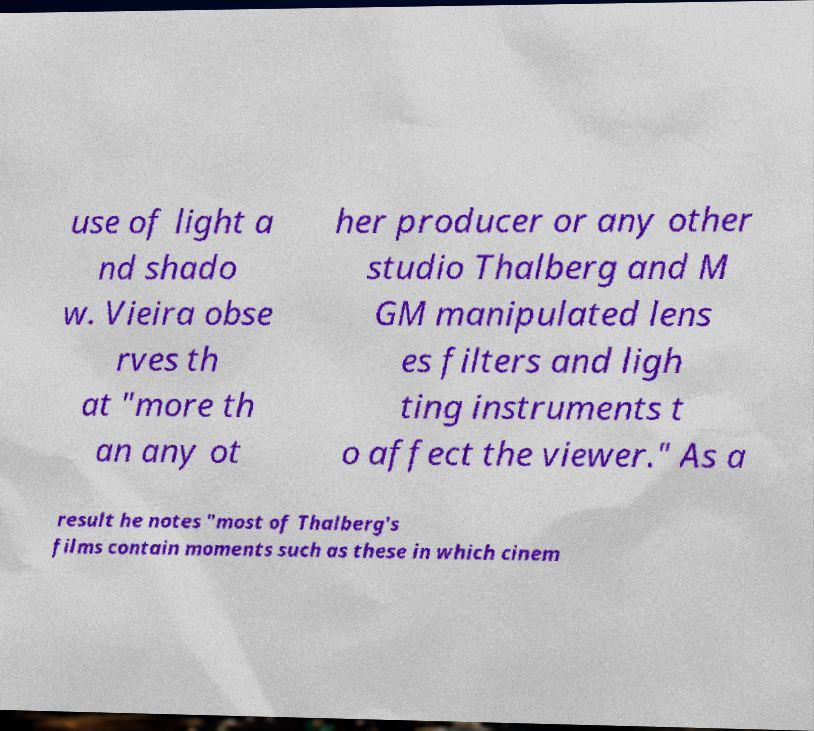Can you read and provide the text displayed in the image?This photo seems to have some interesting text. Can you extract and type it out for me? use of light a nd shado w. Vieira obse rves th at "more th an any ot her producer or any other studio Thalberg and M GM manipulated lens es filters and ligh ting instruments t o affect the viewer." As a result he notes "most of Thalberg's films contain moments such as these in which cinem 